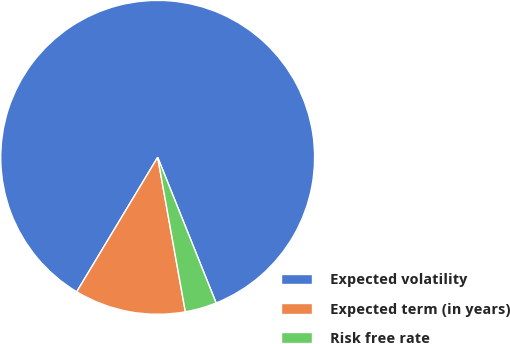Convert chart. <chart><loc_0><loc_0><loc_500><loc_500><pie_chart><fcel>Expected volatility<fcel>Expected term (in years)<fcel>Risk free rate<nl><fcel>85.29%<fcel>11.45%<fcel>3.25%<nl></chart> 